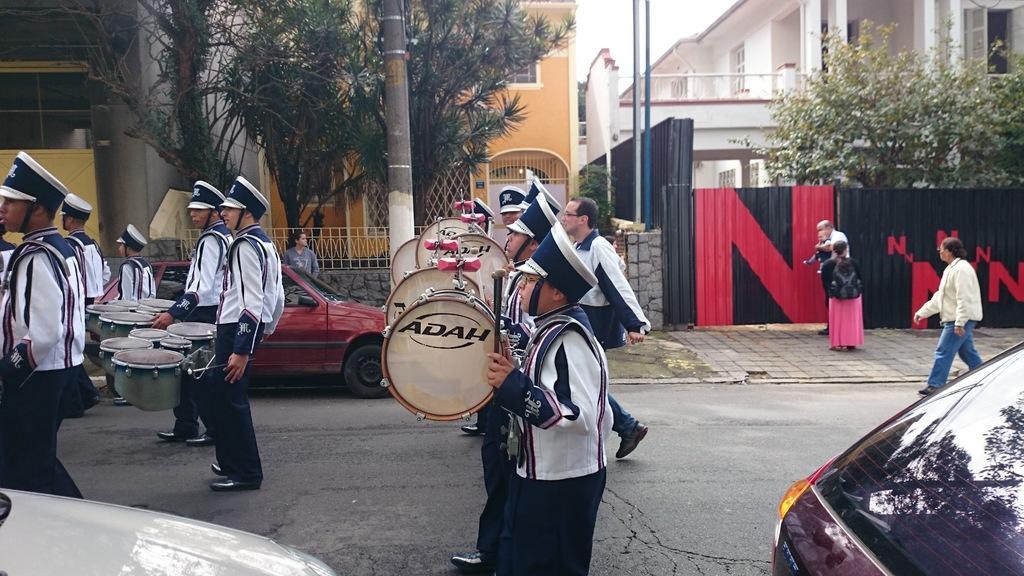How would you summarize this image in a sentence or two? This image is clicked on the road. There are many people walking on the road. They are playing drums. They are wearing uniform. There are cars parked on the road. Behind them there is a walkway. There are a few people on the walkway. Behind them there are buildings. There are walls around the buildings. There is a railing on the wall. In front of the building there are trees and poles. At the top there is a sky. 